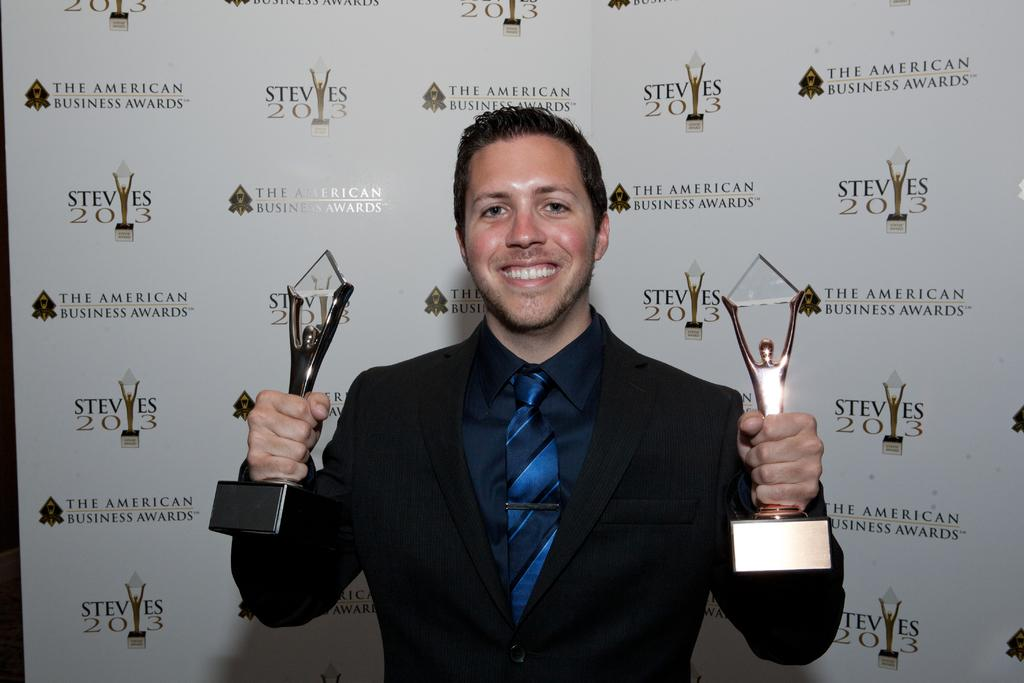Who is present in the image? There is a man in the image. What is the man doing in the image? The man is smiling in the image. What is the man holding in the image? The man is holding two trophies in the image. What can be seen in the background of the image? There is a board in the background of the image. Is there a volcano erupting in the background of the image? No, there is no volcano present in the image. What type of bait is the man using to catch fish in the image? There is no fishing or bait present in the image; the man is holding trophies. 